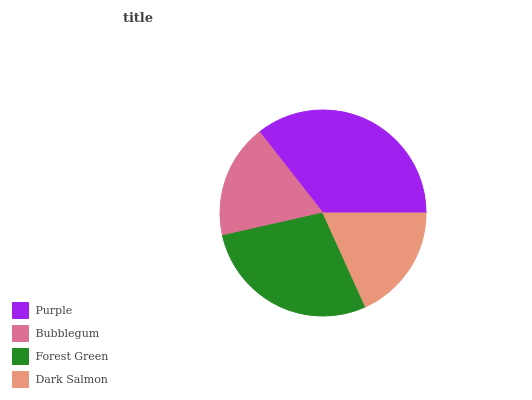Is Bubblegum the minimum?
Answer yes or no. Yes. Is Purple the maximum?
Answer yes or no. Yes. Is Forest Green the minimum?
Answer yes or no. No. Is Forest Green the maximum?
Answer yes or no. No. Is Forest Green greater than Bubblegum?
Answer yes or no. Yes. Is Bubblegum less than Forest Green?
Answer yes or no. Yes. Is Bubblegum greater than Forest Green?
Answer yes or no. No. Is Forest Green less than Bubblegum?
Answer yes or no. No. Is Forest Green the high median?
Answer yes or no. Yes. Is Dark Salmon the low median?
Answer yes or no. Yes. Is Dark Salmon the high median?
Answer yes or no. No. Is Forest Green the low median?
Answer yes or no. No. 